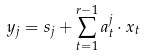<formula> <loc_0><loc_0><loc_500><loc_500>y _ { j } = s _ { j } + \sum ^ { r - 1 } _ { t = 1 } a ^ { j } _ { t } \cdot x _ { t }</formula> 